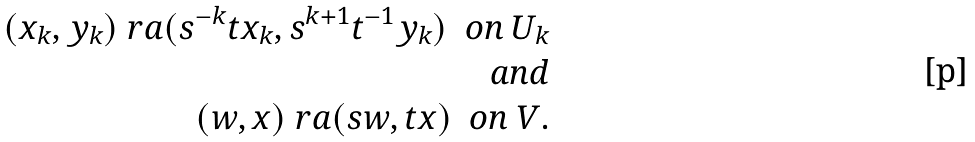Convert formula to latex. <formula><loc_0><loc_0><loc_500><loc_500>( x _ { k } , y _ { k } ) \ r a ( s ^ { - k } t x _ { k } , s ^ { k + 1 } t ^ { - 1 } y _ { k } ) \ \ o n \ U _ { k } \\ a n d \\ ( w , x ) \ r a ( s w , t x ) \ \ o n \ V .</formula> 